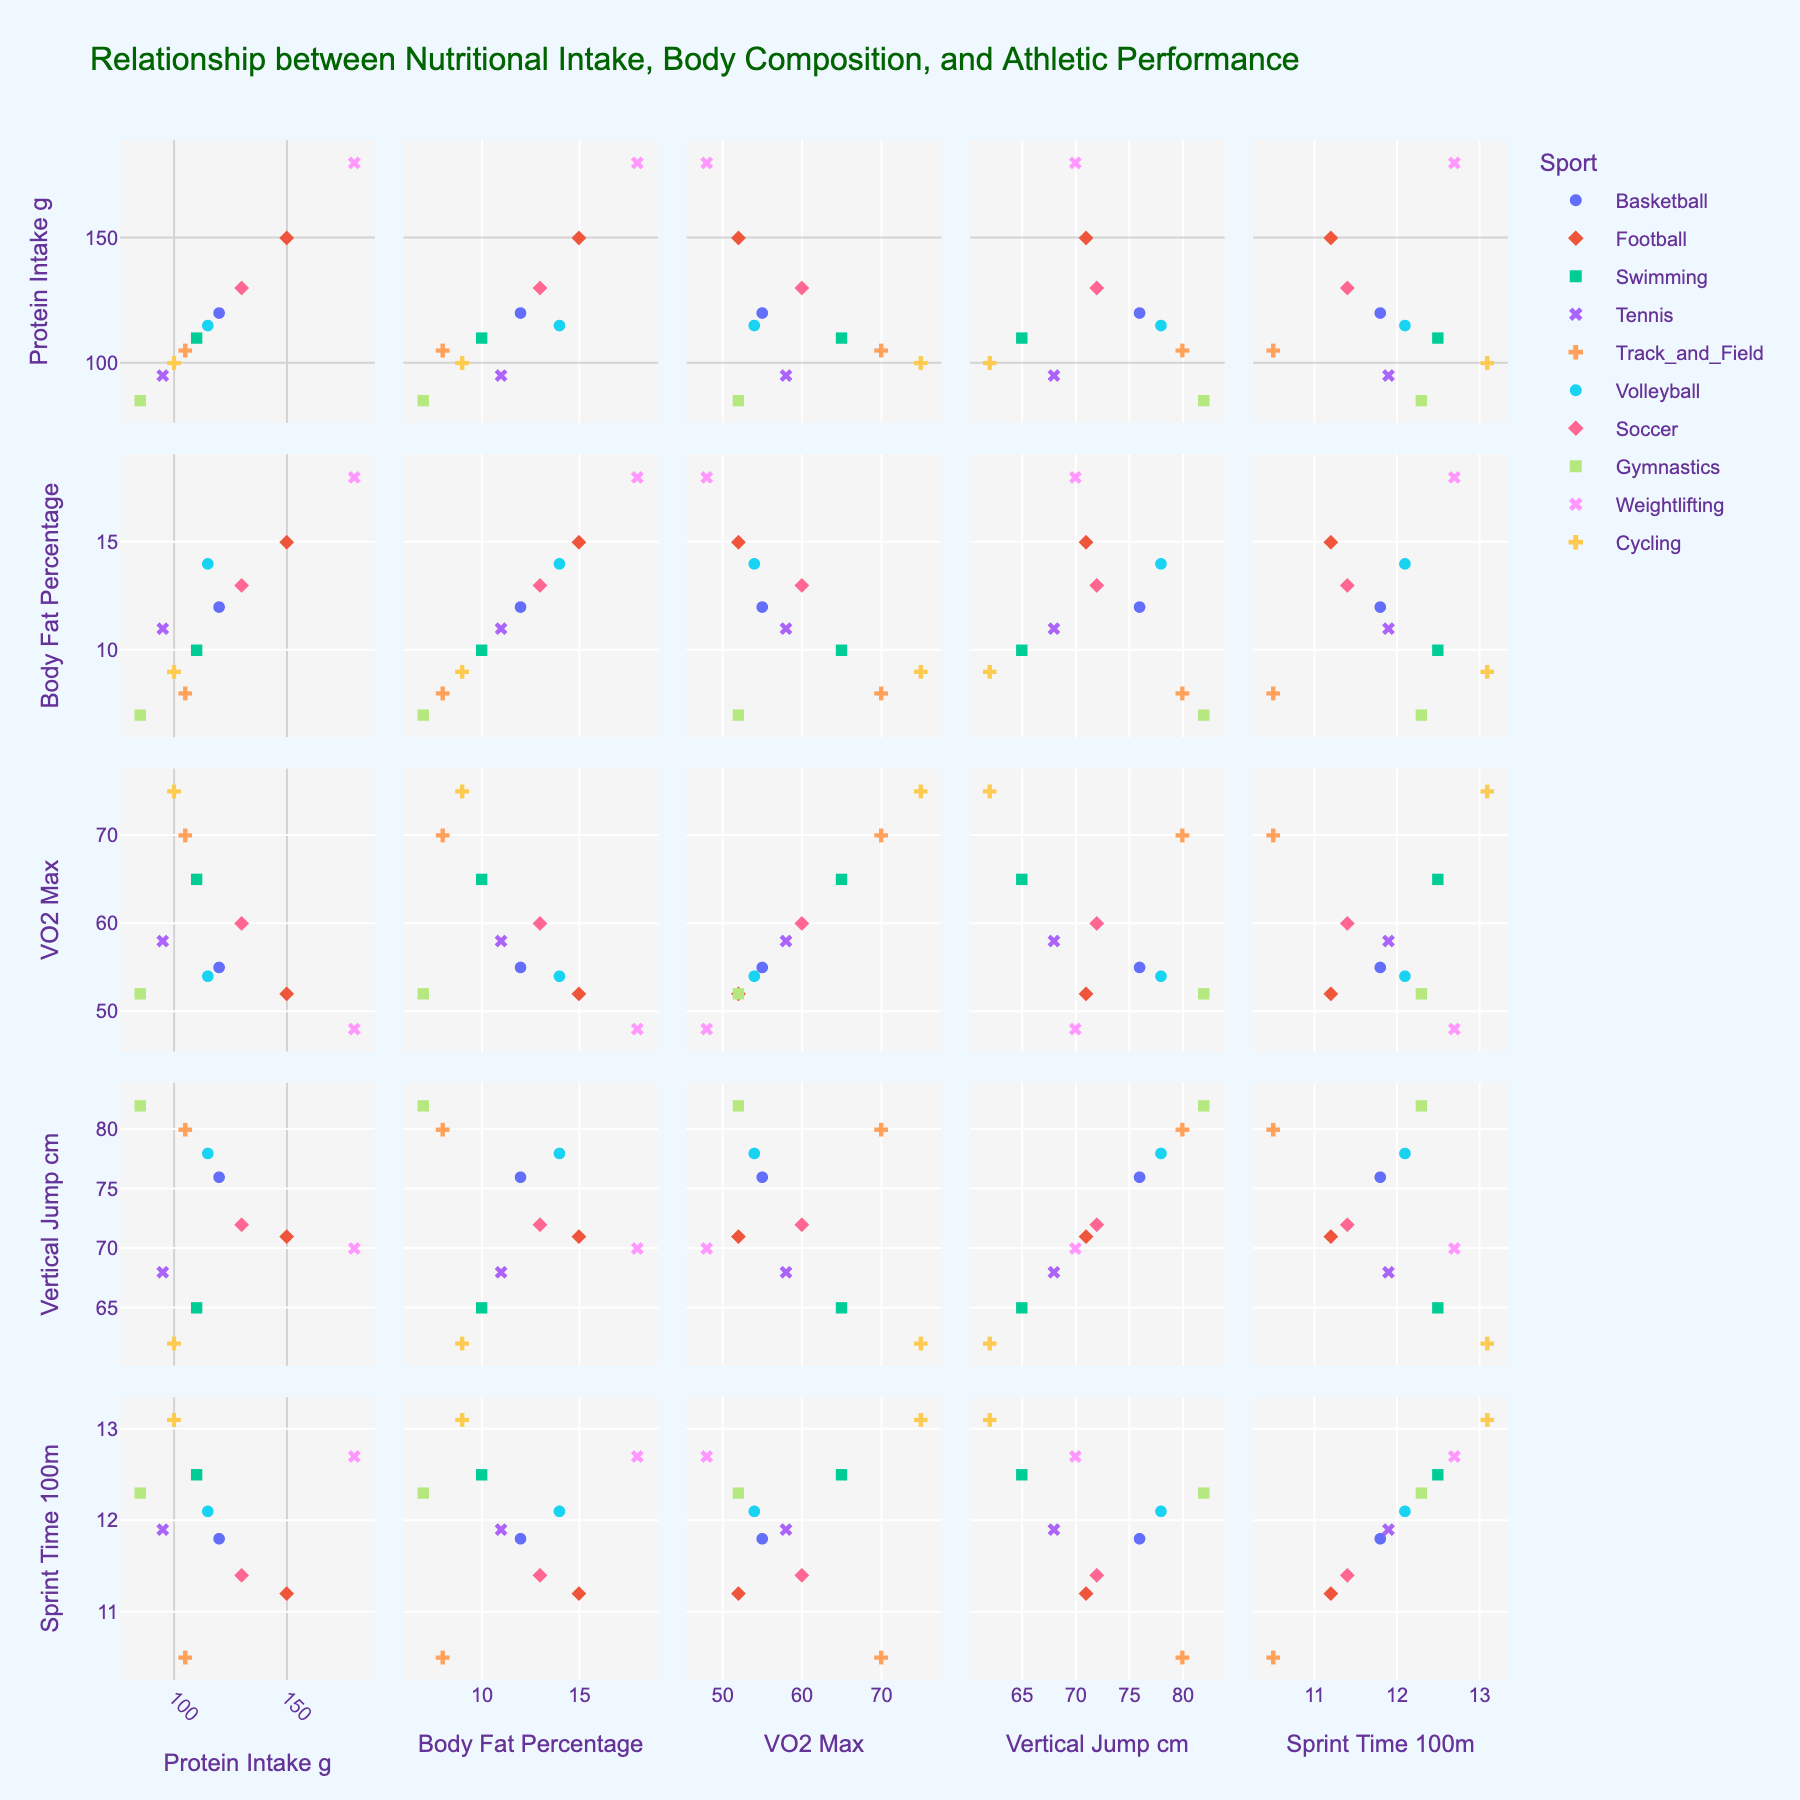Which price range has the highest percentage for T-Shirts? The pie chart for T-Shirts shows that the $10-$20 price range has the largest wedge.
Answer: $10-$20 What is the combined percentage of T-Shirts priced under $10 and over $30? The percentage for T-Shirts under $10 is 30% and over $30 is 5%. Adding these together gives 30% + 5%.
Answer: 35% How does the percentage of Jeans priced over $60 compare to Dresses in the same range? The pie charts show that Jeans over $60 account for 10% while Dresses over $50 also account for 10%, hence they are equal.
Answer: Equal Which category has the highest percentage for the lowest price range? The pie chart for Accessories shows that 35% are priced under $5, which is higher than any other category's lowest price range.
Answer: Accessories What's the most common price range for Dresses? The largest section in the pie chart for Dresses represents the $15-$30 price range.
Answer: $15-$30 What is the total percentage of items priced under $20 across all categories? Under $10 for T-Shirts: 30%, Under $20 for Jeans: 15%, Under $15 for Dresses: 20%, Under $5 for Accessories: 35%. Summing these: 30% + 15% + 20% + 35% = 100%.
Answer: 100% Compare the combined percentage of T-Shirts in the $10-$30 range with Dresses in the $15-$50 range. T-Shirts in $10-$20 is 50% and $20-$30 is 15%, summing to 50% + 15% = 65%. Dresses in $15-$30 is 40% and $30-$50 is 30%, summing to 40% + 30% = 70%.
Answer: Dresses have a higher combined percentage (70% vs. 65%) What percentage of Accessories is priced between $5 and $25? For Accessories, $5-$15 has 45% and $15-$25 has 15%. Summing them gives 45% + 15% = 60%.
Answer: 60% Is the percentage of Jeans priced between $20 and $60 greater than that of Dresses priced between $15 and $50? For Jeans, $20-$40 is 45% and $40-$60 is 30%, summing to 45% + 30% = 75%. For Dresses, $15-$30 is 40% and $30-$50 is 30%, summing to 40% + 30% = 70%.
Answer: Yes, Jeans (75%) 